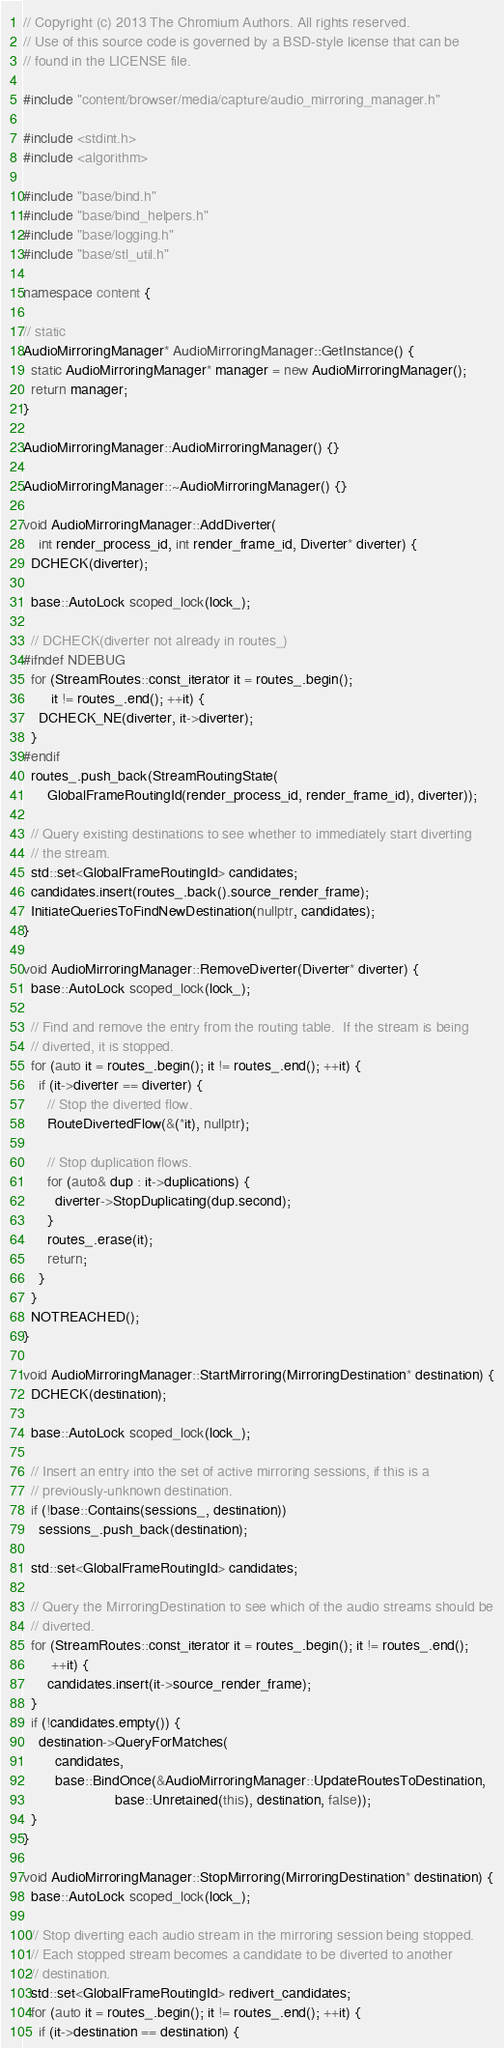<code> <loc_0><loc_0><loc_500><loc_500><_C++_>// Copyright (c) 2013 The Chromium Authors. All rights reserved.
// Use of this source code is governed by a BSD-style license that can be
// found in the LICENSE file.

#include "content/browser/media/capture/audio_mirroring_manager.h"

#include <stdint.h>
#include <algorithm>

#include "base/bind.h"
#include "base/bind_helpers.h"
#include "base/logging.h"
#include "base/stl_util.h"

namespace content {

// static
AudioMirroringManager* AudioMirroringManager::GetInstance() {
  static AudioMirroringManager* manager = new AudioMirroringManager();
  return manager;
}

AudioMirroringManager::AudioMirroringManager() {}

AudioMirroringManager::~AudioMirroringManager() {}

void AudioMirroringManager::AddDiverter(
    int render_process_id, int render_frame_id, Diverter* diverter) {
  DCHECK(diverter);

  base::AutoLock scoped_lock(lock_);

  // DCHECK(diverter not already in routes_)
#ifndef NDEBUG
  for (StreamRoutes::const_iterator it = routes_.begin();
       it != routes_.end(); ++it) {
    DCHECK_NE(diverter, it->diverter);
  }
#endif
  routes_.push_back(StreamRoutingState(
      GlobalFrameRoutingId(render_process_id, render_frame_id), diverter));

  // Query existing destinations to see whether to immediately start diverting
  // the stream.
  std::set<GlobalFrameRoutingId> candidates;
  candidates.insert(routes_.back().source_render_frame);
  InitiateQueriesToFindNewDestination(nullptr, candidates);
}

void AudioMirroringManager::RemoveDiverter(Diverter* diverter) {
  base::AutoLock scoped_lock(lock_);

  // Find and remove the entry from the routing table.  If the stream is being
  // diverted, it is stopped.
  for (auto it = routes_.begin(); it != routes_.end(); ++it) {
    if (it->diverter == diverter) {
      // Stop the diverted flow.
      RouteDivertedFlow(&(*it), nullptr);

      // Stop duplication flows.
      for (auto& dup : it->duplications) {
        diverter->StopDuplicating(dup.second);
      }
      routes_.erase(it);
      return;
    }
  }
  NOTREACHED();
}

void AudioMirroringManager::StartMirroring(MirroringDestination* destination) {
  DCHECK(destination);

  base::AutoLock scoped_lock(lock_);

  // Insert an entry into the set of active mirroring sessions, if this is a
  // previously-unknown destination.
  if (!base::Contains(sessions_, destination))
    sessions_.push_back(destination);

  std::set<GlobalFrameRoutingId> candidates;

  // Query the MirroringDestination to see which of the audio streams should be
  // diverted.
  for (StreamRoutes::const_iterator it = routes_.begin(); it != routes_.end();
       ++it) {
      candidates.insert(it->source_render_frame);
  }
  if (!candidates.empty()) {
    destination->QueryForMatches(
        candidates,
        base::BindOnce(&AudioMirroringManager::UpdateRoutesToDestination,
                       base::Unretained(this), destination, false));
  }
}

void AudioMirroringManager::StopMirroring(MirroringDestination* destination) {
  base::AutoLock scoped_lock(lock_);

  // Stop diverting each audio stream in the mirroring session being stopped.
  // Each stopped stream becomes a candidate to be diverted to another
  // destination.
  std::set<GlobalFrameRoutingId> redivert_candidates;
  for (auto it = routes_.begin(); it != routes_.end(); ++it) {
    if (it->destination == destination) {</code> 